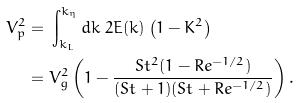<formula> <loc_0><loc_0><loc_500><loc_500>V _ { p } ^ { 2 } = & \ \int _ { k _ { L } } ^ { k _ { \eta } } d k \ 2 E ( k ) \left ( 1 - K ^ { 2 } \right ) \\ = & \ V _ { g } ^ { 2 } \left ( 1 - \frac { S t ^ { 2 } ( 1 - R e ^ { - 1 / 2 } ) } { ( S t + 1 ) ( S t + R e ^ { - 1 / 2 } ) } \right ) .</formula> 